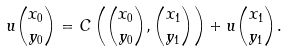<formula> <loc_0><loc_0><loc_500><loc_500>u \binom { x _ { 0 } } { y _ { 0 } } = C \left ( \binom { x _ { 0 } } { y _ { 0 } } , \binom { x _ { 1 } } { y _ { 1 } } \right ) + u \binom { x _ { 1 } } { y _ { 1 } } .</formula> 